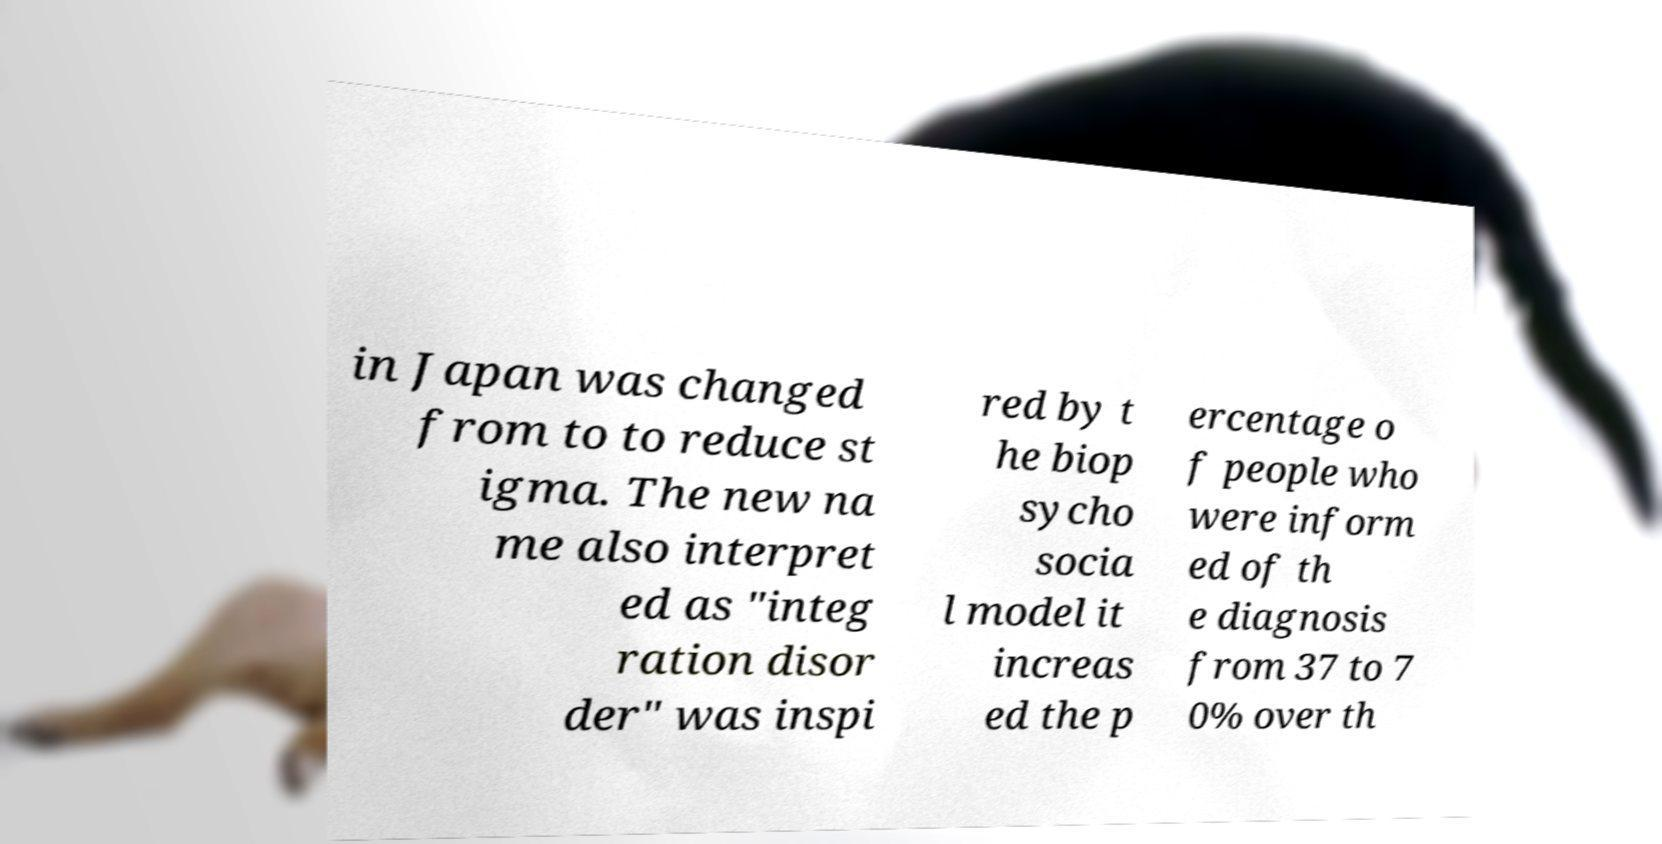Could you assist in decoding the text presented in this image and type it out clearly? in Japan was changed from to to reduce st igma. The new na me also interpret ed as "integ ration disor der" was inspi red by t he biop sycho socia l model it increas ed the p ercentage o f people who were inform ed of th e diagnosis from 37 to 7 0% over th 